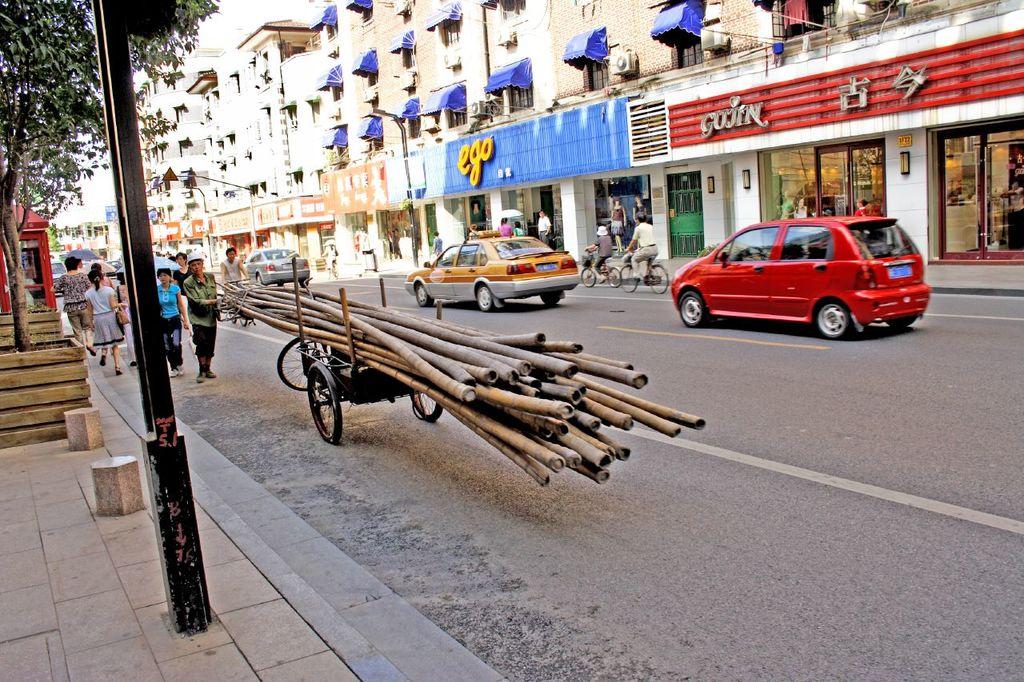What is the store name on the turquoise banner?
Your answer should be compact. Ego. What is the store in red?
Keep it short and to the point. Gojin. 